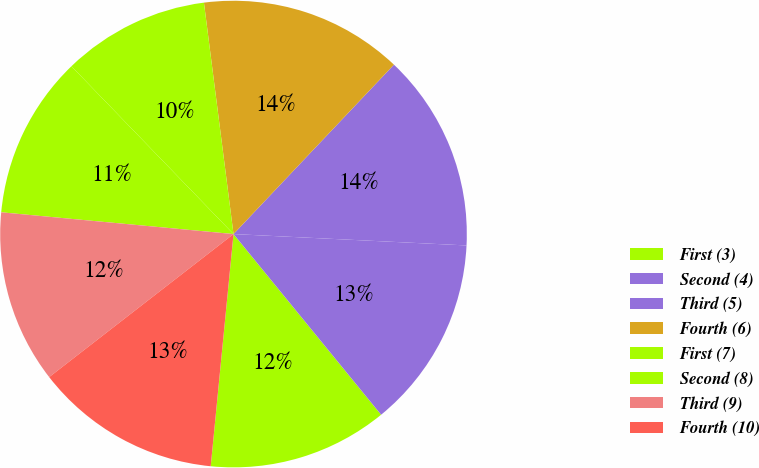Convert chart to OTSL. <chart><loc_0><loc_0><loc_500><loc_500><pie_chart><fcel>First (3)<fcel>Second (4)<fcel>Third (5)<fcel>Fourth (6)<fcel>First (7)<fcel>Second (8)<fcel>Third (9)<fcel>Fourth (10)<nl><fcel>12.46%<fcel>13.32%<fcel>13.71%<fcel>14.09%<fcel>10.2%<fcel>11.29%<fcel>11.99%<fcel>12.94%<nl></chart> 